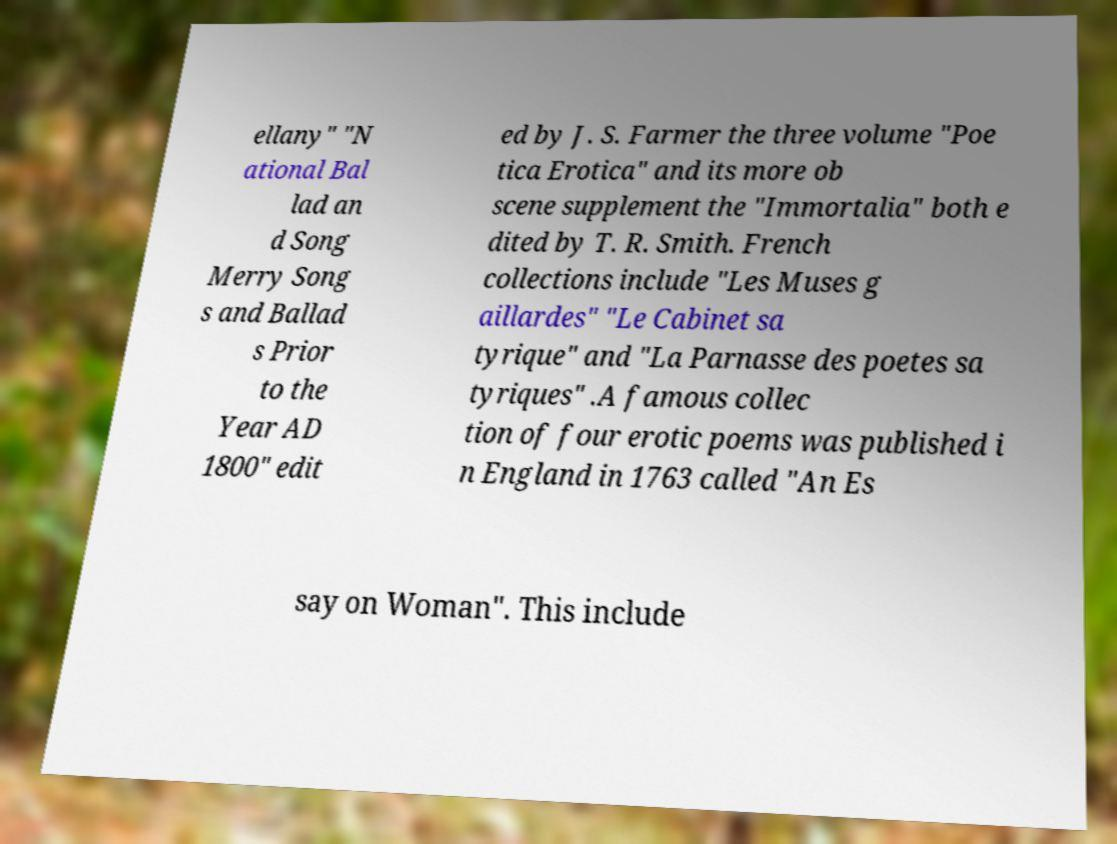What messages or text are displayed in this image? I need them in a readable, typed format. ellany" "N ational Bal lad an d Song Merry Song s and Ballad s Prior to the Year AD 1800" edit ed by J. S. Farmer the three volume "Poe tica Erotica" and its more ob scene supplement the "Immortalia" both e dited by T. R. Smith. French collections include "Les Muses g aillardes" "Le Cabinet sa tyrique" and "La Parnasse des poetes sa tyriques" .A famous collec tion of four erotic poems was published i n England in 1763 called "An Es say on Woman". This include 